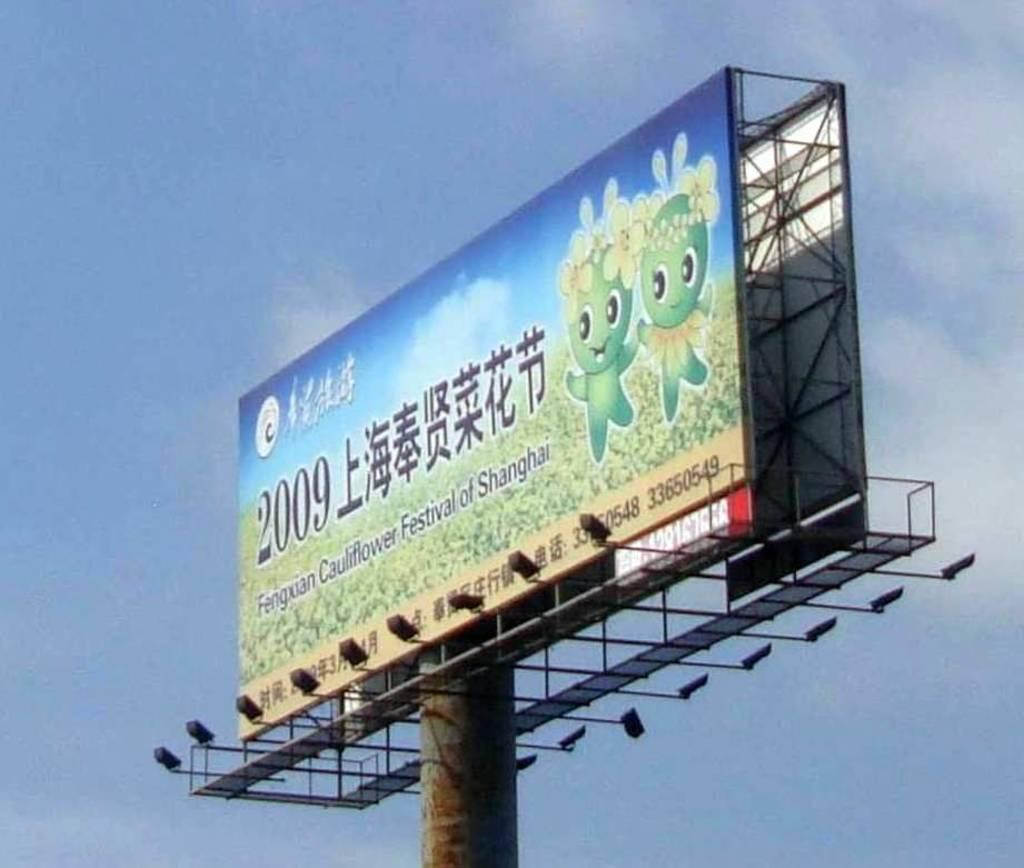<image>
Create a compact narrative representing the image presented. A billboard located in Asia advertising a Cauliflower Festival. 